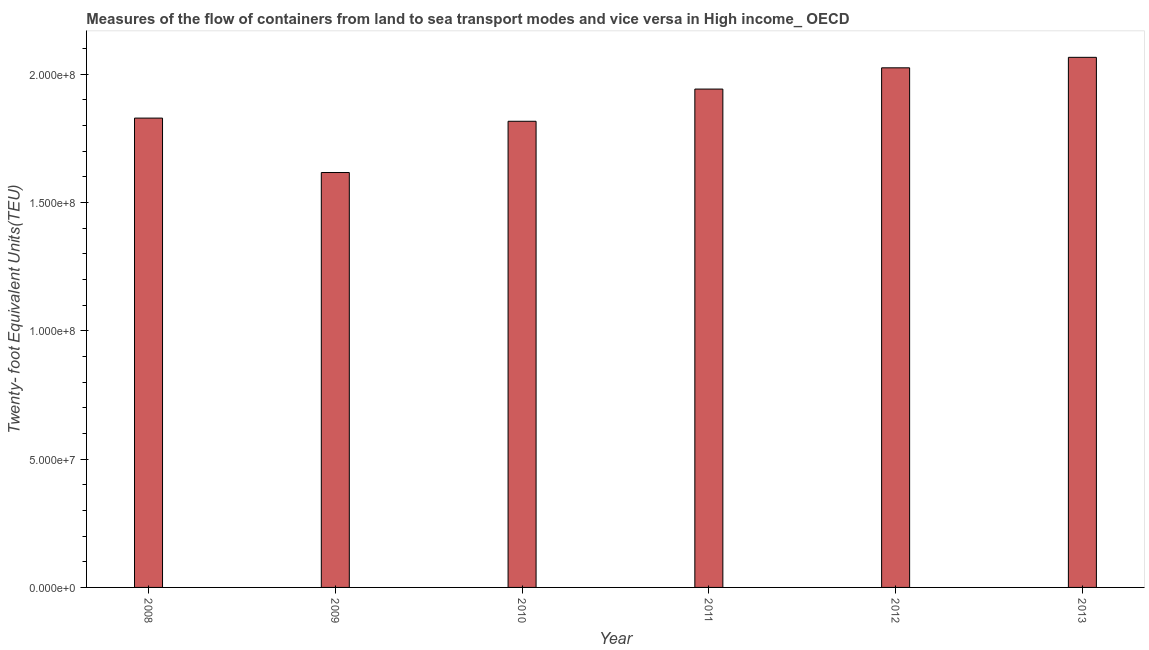What is the title of the graph?
Provide a succinct answer. Measures of the flow of containers from land to sea transport modes and vice versa in High income_ OECD. What is the label or title of the X-axis?
Provide a succinct answer. Year. What is the label or title of the Y-axis?
Ensure brevity in your answer.  Twenty- foot Equivalent Units(TEU). What is the container port traffic in 2012?
Your answer should be compact. 2.03e+08. Across all years, what is the maximum container port traffic?
Your answer should be very brief. 2.07e+08. Across all years, what is the minimum container port traffic?
Your answer should be very brief. 1.62e+08. In which year was the container port traffic minimum?
Your answer should be very brief. 2009. What is the sum of the container port traffic?
Provide a short and direct response. 1.13e+09. What is the difference between the container port traffic in 2010 and 2013?
Provide a short and direct response. -2.49e+07. What is the average container port traffic per year?
Offer a terse response. 1.88e+08. What is the median container port traffic?
Offer a terse response. 1.89e+08. What is the ratio of the container port traffic in 2008 to that in 2013?
Give a very brief answer. 0.89. Is the container port traffic in 2011 less than that in 2013?
Give a very brief answer. Yes. Is the difference between the container port traffic in 2008 and 2009 greater than the difference between any two years?
Your response must be concise. No. What is the difference between the highest and the second highest container port traffic?
Offer a very short reply. 4.09e+06. What is the difference between the highest and the lowest container port traffic?
Offer a terse response. 4.49e+07. In how many years, is the container port traffic greater than the average container port traffic taken over all years?
Your answer should be very brief. 3. How many bars are there?
Your answer should be compact. 6. Are all the bars in the graph horizontal?
Your answer should be compact. No. Are the values on the major ticks of Y-axis written in scientific E-notation?
Your answer should be compact. Yes. What is the Twenty- foot Equivalent Units(TEU) of 2008?
Your answer should be very brief. 1.83e+08. What is the Twenty- foot Equivalent Units(TEU) in 2009?
Keep it short and to the point. 1.62e+08. What is the Twenty- foot Equivalent Units(TEU) in 2010?
Give a very brief answer. 1.82e+08. What is the Twenty- foot Equivalent Units(TEU) in 2011?
Provide a short and direct response. 1.94e+08. What is the Twenty- foot Equivalent Units(TEU) of 2012?
Provide a succinct answer. 2.03e+08. What is the Twenty- foot Equivalent Units(TEU) of 2013?
Keep it short and to the point. 2.07e+08. What is the difference between the Twenty- foot Equivalent Units(TEU) in 2008 and 2009?
Keep it short and to the point. 2.12e+07. What is the difference between the Twenty- foot Equivalent Units(TEU) in 2008 and 2010?
Offer a terse response. 1.24e+06. What is the difference between the Twenty- foot Equivalent Units(TEU) in 2008 and 2011?
Offer a very short reply. -1.13e+07. What is the difference between the Twenty- foot Equivalent Units(TEU) in 2008 and 2012?
Your answer should be very brief. -1.96e+07. What is the difference between the Twenty- foot Equivalent Units(TEU) in 2008 and 2013?
Give a very brief answer. -2.37e+07. What is the difference between the Twenty- foot Equivalent Units(TEU) in 2009 and 2010?
Keep it short and to the point. -2.00e+07. What is the difference between the Twenty- foot Equivalent Units(TEU) in 2009 and 2011?
Your answer should be compact. -3.25e+07. What is the difference between the Twenty- foot Equivalent Units(TEU) in 2009 and 2012?
Provide a short and direct response. -4.08e+07. What is the difference between the Twenty- foot Equivalent Units(TEU) in 2009 and 2013?
Offer a terse response. -4.49e+07. What is the difference between the Twenty- foot Equivalent Units(TEU) in 2010 and 2011?
Ensure brevity in your answer.  -1.25e+07. What is the difference between the Twenty- foot Equivalent Units(TEU) in 2010 and 2012?
Your answer should be very brief. -2.08e+07. What is the difference between the Twenty- foot Equivalent Units(TEU) in 2010 and 2013?
Your response must be concise. -2.49e+07. What is the difference between the Twenty- foot Equivalent Units(TEU) in 2011 and 2012?
Give a very brief answer. -8.28e+06. What is the difference between the Twenty- foot Equivalent Units(TEU) in 2011 and 2013?
Give a very brief answer. -1.24e+07. What is the difference between the Twenty- foot Equivalent Units(TEU) in 2012 and 2013?
Offer a very short reply. -4.09e+06. What is the ratio of the Twenty- foot Equivalent Units(TEU) in 2008 to that in 2009?
Provide a succinct answer. 1.13. What is the ratio of the Twenty- foot Equivalent Units(TEU) in 2008 to that in 2011?
Provide a succinct answer. 0.94. What is the ratio of the Twenty- foot Equivalent Units(TEU) in 2008 to that in 2012?
Provide a succinct answer. 0.9. What is the ratio of the Twenty- foot Equivalent Units(TEU) in 2008 to that in 2013?
Keep it short and to the point. 0.89. What is the ratio of the Twenty- foot Equivalent Units(TEU) in 2009 to that in 2010?
Keep it short and to the point. 0.89. What is the ratio of the Twenty- foot Equivalent Units(TEU) in 2009 to that in 2011?
Give a very brief answer. 0.83. What is the ratio of the Twenty- foot Equivalent Units(TEU) in 2009 to that in 2012?
Give a very brief answer. 0.8. What is the ratio of the Twenty- foot Equivalent Units(TEU) in 2009 to that in 2013?
Your answer should be very brief. 0.78. What is the ratio of the Twenty- foot Equivalent Units(TEU) in 2010 to that in 2011?
Offer a very short reply. 0.94. What is the ratio of the Twenty- foot Equivalent Units(TEU) in 2010 to that in 2012?
Provide a short and direct response. 0.9. What is the ratio of the Twenty- foot Equivalent Units(TEU) in 2010 to that in 2013?
Keep it short and to the point. 0.88. What is the ratio of the Twenty- foot Equivalent Units(TEU) in 2011 to that in 2012?
Offer a very short reply. 0.96. What is the ratio of the Twenty- foot Equivalent Units(TEU) in 2012 to that in 2013?
Ensure brevity in your answer.  0.98. 